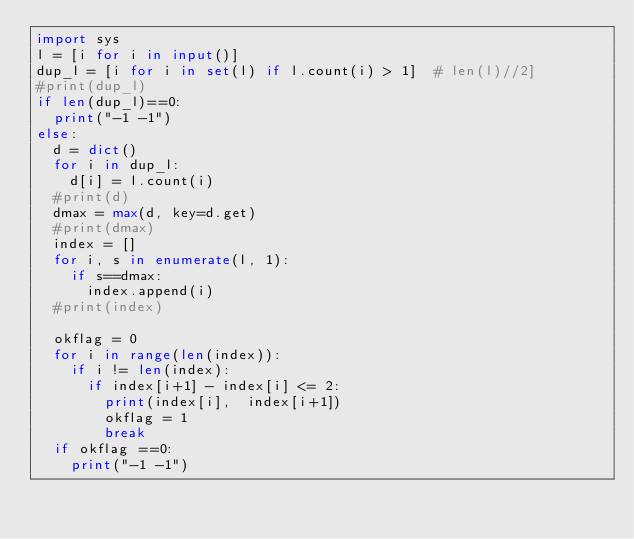<code> <loc_0><loc_0><loc_500><loc_500><_Python_>import sys
l = [i for i in input()]
dup_l = [i for i in set(l) if l.count(i) > 1]  # len(l)//2]
#print(dup_l)
if len(dup_l)==0:
  print("-1 -1")
else:
  d = dict()
  for i in dup_l:
    d[i] = l.count(i)
  #print(d)
  dmax = max(d, key=d.get)
  #print(dmax)
  index = []
  for i, s in enumerate(l, 1):
    if s==dmax:
      index.append(i)
  #print(index)

  okflag = 0
  for i in range(len(index)):
    if i != len(index):
      if index[i+1] - index[i] <= 2:
        print(index[i],  index[i+1])
        okflag = 1
        break
  if okflag ==0:
    print("-1 -1")</code> 